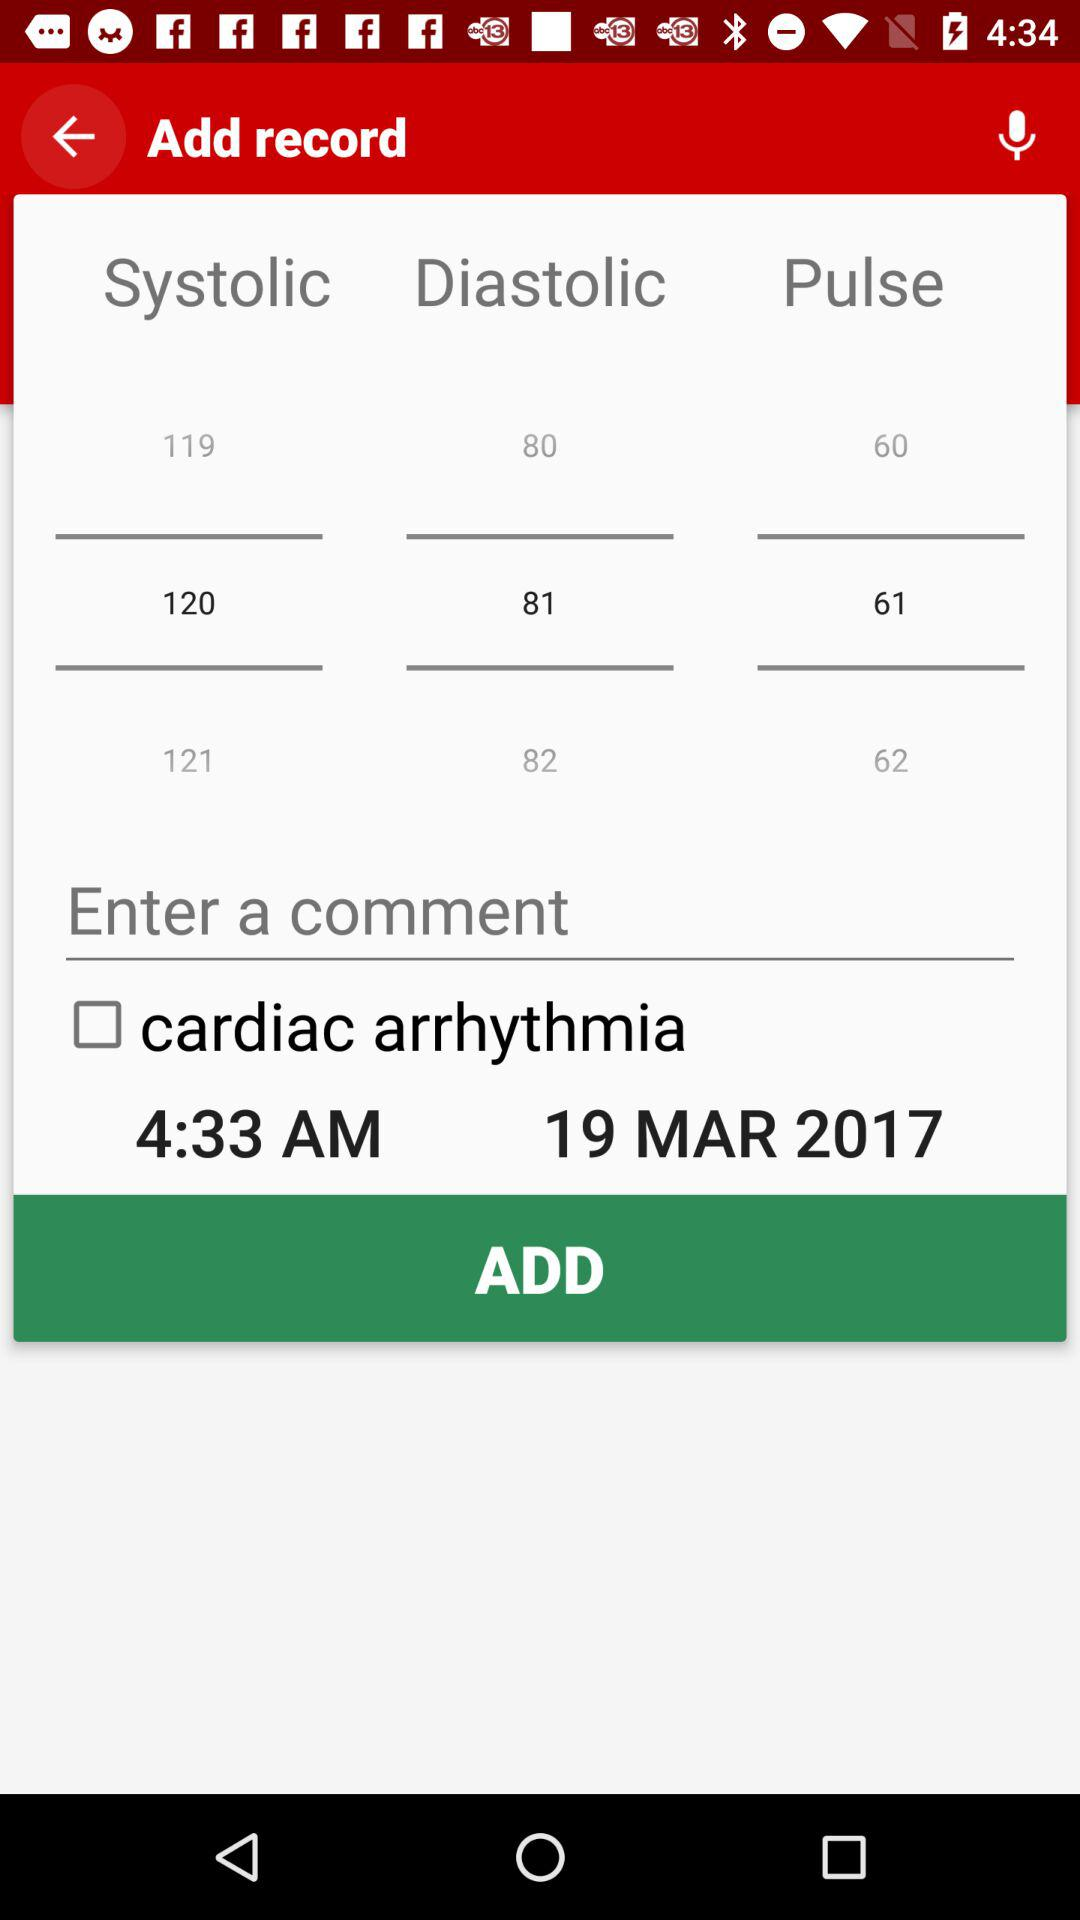What is the status of "cardiac arrhythmia"? The status is "off". 